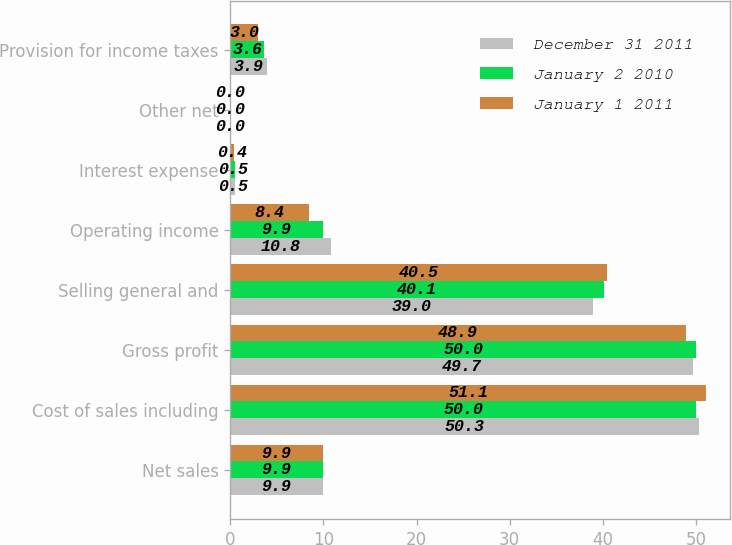Convert chart to OTSL. <chart><loc_0><loc_0><loc_500><loc_500><stacked_bar_chart><ecel><fcel>Net sales<fcel>Cost of sales including<fcel>Gross profit<fcel>Selling general and<fcel>Operating income<fcel>Interest expense<fcel>Other net<fcel>Provision for income taxes<nl><fcel>December 31 2011<fcel>9.9<fcel>50.3<fcel>49.7<fcel>39<fcel>10.8<fcel>0.5<fcel>0<fcel>3.9<nl><fcel>January 2 2010<fcel>9.9<fcel>50<fcel>50<fcel>40.1<fcel>9.9<fcel>0.5<fcel>0<fcel>3.6<nl><fcel>January 1 2011<fcel>9.9<fcel>51.1<fcel>48.9<fcel>40.5<fcel>8.4<fcel>0.4<fcel>0<fcel>3<nl></chart> 